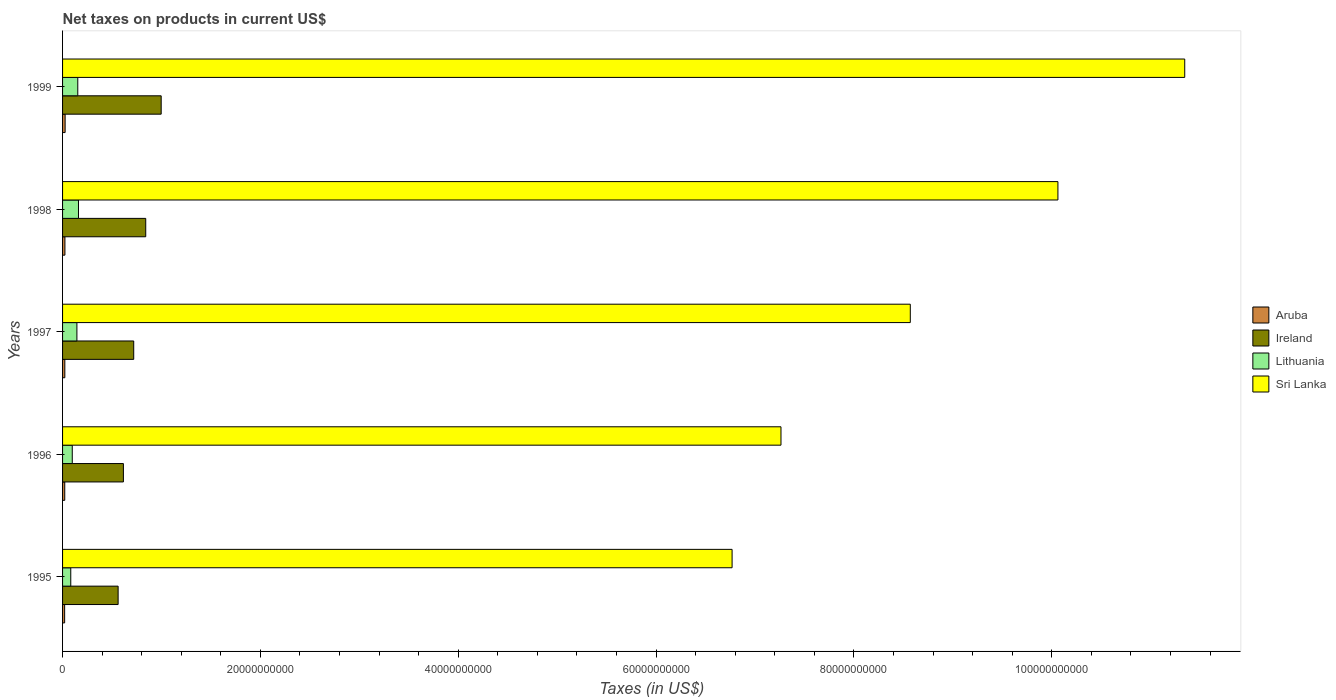How many different coloured bars are there?
Make the answer very short. 4. Are the number of bars per tick equal to the number of legend labels?
Your response must be concise. Yes. How many bars are there on the 4th tick from the top?
Offer a very short reply. 4. What is the label of the 5th group of bars from the top?
Provide a succinct answer. 1995. What is the net taxes on products in Ireland in 1998?
Provide a short and direct response. 8.41e+09. Across all years, what is the maximum net taxes on products in Aruba?
Your answer should be very brief. 2.59e+08. Across all years, what is the minimum net taxes on products in Aruba?
Provide a succinct answer. 2.09e+08. In which year was the net taxes on products in Aruba maximum?
Provide a succinct answer. 1999. In which year was the net taxes on products in Lithuania minimum?
Provide a short and direct response. 1995. What is the total net taxes on products in Ireland in the graph?
Provide a short and direct response. 3.73e+1. What is the difference between the net taxes on products in Ireland in 1998 and that in 1999?
Make the answer very short. -1.56e+09. What is the difference between the net taxes on products in Sri Lanka in 1998 and the net taxes on products in Lithuania in 1995?
Provide a succinct answer. 9.98e+1. What is the average net taxes on products in Ireland per year?
Ensure brevity in your answer.  7.47e+09. In the year 1998, what is the difference between the net taxes on products in Aruba and net taxes on products in Lithuania?
Make the answer very short. -1.37e+09. In how many years, is the net taxes on products in Lithuania greater than 84000000000 US$?
Keep it short and to the point. 0. What is the ratio of the net taxes on products in Lithuania in 1998 to that in 1999?
Your answer should be very brief. 1.05. Is the difference between the net taxes on products in Aruba in 1996 and 1999 greater than the difference between the net taxes on products in Lithuania in 1996 and 1999?
Your answer should be compact. Yes. What is the difference between the highest and the second highest net taxes on products in Ireland?
Your answer should be compact. 1.56e+09. What is the difference between the highest and the lowest net taxes on products in Ireland?
Offer a very short reply. 4.35e+09. In how many years, is the net taxes on products in Ireland greater than the average net taxes on products in Ireland taken over all years?
Your answer should be compact. 2. Is it the case that in every year, the sum of the net taxes on products in Sri Lanka and net taxes on products in Lithuania is greater than the sum of net taxes on products in Ireland and net taxes on products in Aruba?
Your response must be concise. Yes. What does the 3rd bar from the top in 1998 represents?
Your answer should be very brief. Ireland. What does the 2nd bar from the bottom in 1999 represents?
Your response must be concise. Ireland. How many bars are there?
Keep it short and to the point. 20. Are all the bars in the graph horizontal?
Offer a terse response. Yes. What is the difference between two consecutive major ticks on the X-axis?
Keep it short and to the point. 2.00e+1. Are the values on the major ticks of X-axis written in scientific E-notation?
Offer a very short reply. No. Does the graph contain any zero values?
Keep it short and to the point. No. Where does the legend appear in the graph?
Offer a very short reply. Center right. How are the legend labels stacked?
Ensure brevity in your answer.  Vertical. What is the title of the graph?
Keep it short and to the point. Net taxes on products in current US$. Does "Europe(developing only)" appear as one of the legend labels in the graph?
Ensure brevity in your answer.  No. What is the label or title of the X-axis?
Your answer should be compact. Taxes (in US$). What is the Taxes (in US$) in Aruba in 1995?
Offer a very short reply. 2.09e+08. What is the Taxes (in US$) of Ireland in 1995?
Your answer should be very brief. 5.62e+09. What is the Taxes (in US$) in Lithuania in 1995?
Make the answer very short. 8.29e+08. What is the Taxes (in US$) of Sri Lanka in 1995?
Ensure brevity in your answer.  6.77e+1. What is the Taxes (in US$) of Aruba in 1996?
Your response must be concise. 2.21e+08. What is the Taxes (in US$) of Ireland in 1996?
Offer a very short reply. 6.15e+09. What is the Taxes (in US$) in Lithuania in 1996?
Offer a terse response. 9.80e+08. What is the Taxes (in US$) of Sri Lanka in 1996?
Offer a very short reply. 7.26e+1. What is the Taxes (in US$) in Aruba in 1997?
Give a very brief answer. 2.29e+08. What is the Taxes (in US$) in Ireland in 1997?
Make the answer very short. 7.19e+09. What is the Taxes (in US$) in Lithuania in 1997?
Your answer should be compact. 1.45e+09. What is the Taxes (in US$) in Sri Lanka in 1997?
Ensure brevity in your answer.  8.57e+1. What is the Taxes (in US$) in Aruba in 1998?
Ensure brevity in your answer.  2.38e+08. What is the Taxes (in US$) of Ireland in 1998?
Your answer should be compact. 8.41e+09. What is the Taxes (in US$) in Lithuania in 1998?
Keep it short and to the point. 1.61e+09. What is the Taxes (in US$) in Sri Lanka in 1998?
Your answer should be compact. 1.01e+11. What is the Taxes (in US$) of Aruba in 1999?
Your answer should be very brief. 2.59e+08. What is the Taxes (in US$) of Ireland in 1999?
Ensure brevity in your answer.  9.97e+09. What is the Taxes (in US$) in Lithuania in 1999?
Your answer should be compact. 1.54e+09. What is the Taxes (in US$) in Sri Lanka in 1999?
Your response must be concise. 1.13e+11. Across all years, what is the maximum Taxes (in US$) of Aruba?
Offer a very short reply. 2.59e+08. Across all years, what is the maximum Taxes (in US$) in Ireland?
Ensure brevity in your answer.  9.97e+09. Across all years, what is the maximum Taxes (in US$) of Lithuania?
Make the answer very short. 1.61e+09. Across all years, what is the maximum Taxes (in US$) of Sri Lanka?
Your answer should be compact. 1.13e+11. Across all years, what is the minimum Taxes (in US$) in Aruba?
Offer a very short reply. 2.09e+08. Across all years, what is the minimum Taxes (in US$) in Ireland?
Give a very brief answer. 5.62e+09. Across all years, what is the minimum Taxes (in US$) in Lithuania?
Provide a short and direct response. 8.29e+08. Across all years, what is the minimum Taxes (in US$) in Sri Lanka?
Ensure brevity in your answer.  6.77e+1. What is the total Taxes (in US$) of Aruba in the graph?
Keep it short and to the point. 1.16e+09. What is the total Taxes (in US$) in Ireland in the graph?
Your answer should be very brief. 3.73e+1. What is the total Taxes (in US$) of Lithuania in the graph?
Offer a very short reply. 6.41e+09. What is the total Taxes (in US$) in Sri Lanka in the graph?
Your answer should be compact. 4.40e+11. What is the difference between the Taxes (in US$) in Aruba in 1995 and that in 1996?
Provide a short and direct response. -1.20e+07. What is the difference between the Taxes (in US$) of Ireland in 1995 and that in 1996?
Your response must be concise. -5.33e+08. What is the difference between the Taxes (in US$) of Lithuania in 1995 and that in 1996?
Offer a terse response. -1.52e+08. What is the difference between the Taxes (in US$) of Sri Lanka in 1995 and that in 1996?
Give a very brief answer. -4.94e+09. What is the difference between the Taxes (in US$) of Aruba in 1995 and that in 1997?
Ensure brevity in your answer.  -2.00e+07. What is the difference between the Taxes (in US$) in Ireland in 1995 and that in 1997?
Provide a short and direct response. -1.58e+09. What is the difference between the Taxes (in US$) in Lithuania in 1995 and that in 1997?
Provide a succinct answer. -6.21e+08. What is the difference between the Taxes (in US$) in Sri Lanka in 1995 and that in 1997?
Make the answer very short. -1.80e+1. What is the difference between the Taxes (in US$) in Aruba in 1995 and that in 1998?
Give a very brief answer. -2.95e+07. What is the difference between the Taxes (in US$) of Ireland in 1995 and that in 1998?
Offer a very short reply. -2.79e+09. What is the difference between the Taxes (in US$) of Lithuania in 1995 and that in 1998?
Provide a succinct answer. -7.80e+08. What is the difference between the Taxes (in US$) of Sri Lanka in 1995 and that in 1998?
Give a very brief answer. -3.29e+1. What is the difference between the Taxes (in US$) in Aruba in 1995 and that in 1999?
Offer a terse response. -4.98e+07. What is the difference between the Taxes (in US$) in Ireland in 1995 and that in 1999?
Your answer should be very brief. -4.35e+09. What is the difference between the Taxes (in US$) of Lithuania in 1995 and that in 1999?
Your answer should be very brief. -7.10e+08. What is the difference between the Taxes (in US$) of Sri Lanka in 1995 and that in 1999?
Give a very brief answer. -4.58e+1. What is the difference between the Taxes (in US$) of Aruba in 1996 and that in 1997?
Your answer should be compact. -8.00e+06. What is the difference between the Taxes (in US$) in Ireland in 1996 and that in 1997?
Offer a very short reply. -1.04e+09. What is the difference between the Taxes (in US$) in Lithuania in 1996 and that in 1997?
Make the answer very short. -4.69e+08. What is the difference between the Taxes (in US$) in Sri Lanka in 1996 and that in 1997?
Ensure brevity in your answer.  -1.31e+1. What is the difference between the Taxes (in US$) in Aruba in 1996 and that in 1998?
Keep it short and to the point. -1.75e+07. What is the difference between the Taxes (in US$) of Ireland in 1996 and that in 1998?
Your answer should be very brief. -2.26e+09. What is the difference between the Taxes (in US$) of Lithuania in 1996 and that in 1998?
Provide a succinct answer. -6.28e+08. What is the difference between the Taxes (in US$) in Sri Lanka in 1996 and that in 1998?
Ensure brevity in your answer.  -2.80e+1. What is the difference between the Taxes (in US$) of Aruba in 1996 and that in 1999?
Offer a terse response. -3.78e+07. What is the difference between the Taxes (in US$) of Ireland in 1996 and that in 1999?
Your response must be concise. -3.82e+09. What is the difference between the Taxes (in US$) of Lithuania in 1996 and that in 1999?
Give a very brief answer. -5.58e+08. What is the difference between the Taxes (in US$) in Sri Lanka in 1996 and that in 1999?
Give a very brief answer. -4.08e+1. What is the difference between the Taxes (in US$) of Aruba in 1997 and that in 1998?
Offer a terse response. -9.46e+06. What is the difference between the Taxes (in US$) of Ireland in 1997 and that in 1998?
Provide a short and direct response. -1.21e+09. What is the difference between the Taxes (in US$) of Lithuania in 1997 and that in 1998?
Make the answer very short. -1.60e+08. What is the difference between the Taxes (in US$) of Sri Lanka in 1997 and that in 1998?
Offer a terse response. -1.49e+1. What is the difference between the Taxes (in US$) of Aruba in 1997 and that in 1999?
Make the answer very short. -2.98e+07. What is the difference between the Taxes (in US$) in Ireland in 1997 and that in 1999?
Your answer should be compact. -2.78e+09. What is the difference between the Taxes (in US$) of Lithuania in 1997 and that in 1999?
Your response must be concise. -8.92e+07. What is the difference between the Taxes (in US$) in Sri Lanka in 1997 and that in 1999?
Your answer should be very brief. -2.77e+1. What is the difference between the Taxes (in US$) in Aruba in 1998 and that in 1999?
Your answer should be compact. -2.03e+07. What is the difference between the Taxes (in US$) of Ireland in 1998 and that in 1999?
Make the answer very short. -1.56e+09. What is the difference between the Taxes (in US$) of Lithuania in 1998 and that in 1999?
Keep it short and to the point. 7.05e+07. What is the difference between the Taxes (in US$) of Sri Lanka in 1998 and that in 1999?
Keep it short and to the point. -1.28e+1. What is the difference between the Taxes (in US$) in Aruba in 1995 and the Taxes (in US$) in Ireland in 1996?
Your answer should be compact. -5.94e+09. What is the difference between the Taxes (in US$) in Aruba in 1995 and the Taxes (in US$) in Lithuania in 1996?
Offer a terse response. -7.71e+08. What is the difference between the Taxes (in US$) in Aruba in 1995 and the Taxes (in US$) in Sri Lanka in 1996?
Make the answer very short. -7.24e+1. What is the difference between the Taxes (in US$) of Ireland in 1995 and the Taxes (in US$) of Lithuania in 1996?
Give a very brief answer. 4.64e+09. What is the difference between the Taxes (in US$) of Ireland in 1995 and the Taxes (in US$) of Sri Lanka in 1996?
Your answer should be very brief. -6.70e+1. What is the difference between the Taxes (in US$) in Lithuania in 1995 and the Taxes (in US$) in Sri Lanka in 1996?
Offer a terse response. -7.18e+1. What is the difference between the Taxes (in US$) of Aruba in 1995 and the Taxes (in US$) of Ireland in 1997?
Offer a terse response. -6.98e+09. What is the difference between the Taxes (in US$) of Aruba in 1995 and the Taxes (in US$) of Lithuania in 1997?
Ensure brevity in your answer.  -1.24e+09. What is the difference between the Taxes (in US$) in Aruba in 1995 and the Taxes (in US$) in Sri Lanka in 1997?
Your answer should be compact. -8.55e+1. What is the difference between the Taxes (in US$) of Ireland in 1995 and the Taxes (in US$) of Lithuania in 1997?
Ensure brevity in your answer.  4.17e+09. What is the difference between the Taxes (in US$) of Ireland in 1995 and the Taxes (in US$) of Sri Lanka in 1997?
Ensure brevity in your answer.  -8.01e+1. What is the difference between the Taxes (in US$) in Lithuania in 1995 and the Taxes (in US$) in Sri Lanka in 1997?
Offer a very short reply. -8.49e+1. What is the difference between the Taxes (in US$) in Aruba in 1995 and the Taxes (in US$) in Ireland in 1998?
Provide a short and direct response. -8.20e+09. What is the difference between the Taxes (in US$) in Aruba in 1995 and the Taxes (in US$) in Lithuania in 1998?
Keep it short and to the point. -1.40e+09. What is the difference between the Taxes (in US$) of Aruba in 1995 and the Taxes (in US$) of Sri Lanka in 1998?
Ensure brevity in your answer.  -1.00e+11. What is the difference between the Taxes (in US$) of Ireland in 1995 and the Taxes (in US$) of Lithuania in 1998?
Your response must be concise. 4.01e+09. What is the difference between the Taxes (in US$) of Ireland in 1995 and the Taxes (in US$) of Sri Lanka in 1998?
Your answer should be very brief. -9.50e+1. What is the difference between the Taxes (in US$) of Lithuania in 1995 and the Taxes (in US$) of Sri Lanka in 1998?
Offer a terse response. -9.98e+1. What is the difference between the Taxes (in US$) of Aruba in 1995 and the Taxes (in US$) of Ireland in 1999?
Your answer should be very brief. -9.76e+09. What is the difference between the Taxes (in US$) in Aruba in 1995 and the Taxes (in US$) in Lithuania in 1999?
Provide a succinct answer. -1.33e+09. What is the difference between the Taxes (in US$) in Aruba in 1995 and the Taxes (in US$) in Sri Lanka in 1999?
Your answer should be very brief. -1.13e+11. What is the difference between the Taxes (in US$) in Ireland in 1995 and the Taxes (in US$) in Lithuania in 1999?
Your answer should be compact. 4.08e+09. What is the difference between the Taxes (in US$) of Ireland in 1995 and the Taxes (in US$) of Sri Lanka in 1999?
Your answer should be very brief. -1.08e+11. What is the difference between the Taxes (in US$) in Lithuania in 1995 and the Taxes (in US$) in Sri Lanka in 1999?
Your answer should be compact. -1.13e+11. What is the difference between the Taxes (in US$) in Aruba in 1996 and the Taxes (in US$) in Ireland in 1997?
Keep it short and to the point. -6.97e+09. What is the difference between the Taxes (in US$) of Aruba in 1996 and the Taxes (in US$) of Lithuania in 1997?
Ensure brevity in your answer.  -1.23e+09. What is the difference between the Taxes (in US$) of Aruba in 1996 and the Taxes (in US$) of Sri Lanka in 1997?
Give a very brief answer. -8.55e+1. What is the difference between the Taxes (in US$) in Ireland in 1996 and the Taxes (in US$) in Lithuania in 1997?
Provide a short and direct response. 4.70e+09. What is the difference between the Taxes (in US$) in Ireland in 1996 and the Taxes (in US$) in Sri Lanka in 1997?
Keep it short and to the point. -7.95e+1. What is the difference between the Taxes (in US$) in Lithuania in 1996 and the Taxes (in US$) in Sri Lanka in 1997?
Offer a very short reply. -8.47e+1. What is the difference between the Taxes (in US$) in Aruba in 1996 and the Taxes (in US$) in Ireland in 1998?
Give a very brief answer. -8.19e+09. What is the difference between the Taxes (in US$) in Aruba in 1996 and the Taxes (in US$) in Lithuania in 1998?
Provide a short and direct response. -1.39e+09. What is the difference between the Taxes (in US$) of Aruba in 1996 and the Taxes (in US$) of Sri Lanka in 1998?
Give a very brief answer. -1.00e+11. What is the difference between the Taxes (in US$) of Ireland in 1996 and the Taxes (in US$) of Lithuania in 1998?
Your answer should be compact. 4.54e+09. What is the difference between the Taxes (in US$) in Ireland in 1996 and the Taxes (in US$) in Sri Lanka in 1998?
Offer a very short reply. -9.45e+1. What is the difference between the Taxes (in US$) in Lithuania in 1996 and the Taxes (in US$) in Sri Lanka in 1998?
Give a very brief answer. -9.96e+1. What is the difference between the Taxes (in US$) in Aruba in 1996 and the Taxes (in US$) in Ireland in 1999?
Give a very brief answer. -9.75e+09. What is the difference between the Taxes (in US$) of Aruba in 1996 and the Taxes (in US$) of Lithuania in 1999?
Provide a succinct answer. -1.32e+09. What is the difference between the Taxes (in US$) of Aruba in 1996 and the Taxes (in US$) of Sri Lanka in 1999?
Your response must be concise. -1.13e+11. What is the difference between the Taxes (in US$) in Ireland in 1996 and the Taxes (in US$) in Lithuania in 1999?
Ensure brevity in your answer.  4.61e+09. What is the difference between the Taxes (in US$) of Ireland in 1996 and the Taxes (in US$) of Sri Lanka in 1999?
Make the answer very short. -1.07e+11. What is the difference between the Taxes (in US$) in Lithuania in 1996 and the Taxes (in US$) in Sri Lanka in 1999?
Your answer should be very brief. -1.12e+11. What is the difference between the Taxes (in US$) in Aruba in 1997 and the Taxes (in US$) in Ireland in 1998?
Offer a very short reply. -8.18e+09. What is the difference between the Taxes (in US$) in Aruba in 1997 and the Taxes (in US$) in Lithuania in 1998?
Provide a short and direct response. -1.38e+09. What is the difference between the Taxes (in US$) in Aruba in 1997 and the Taxes (in US$) in Sri Lanka in 1998?
Keep it short and to the point. -1.00e+11. What is the difference between the Taxes (in US$) in Ireland in 1997 and the Taxes (in US$) in Lithuania in 1998?
Make the answer very short. 5.58e+09. What is the difference between the Taxes (in US$) of Ireland in 1997 and the Taxes (in US$) of Sri Lanka in 1998?
Make the answer very short. -9.34e+1. What is the difference between the Taxes (in US$) in Lithuania in 1997 and the Taxes (in US$) in Sri Lanka in 1998?
Offer a terse response. -9.92e+1. What is the difference between the Taxes (in US$) in Aruba in 1997 and the Taxes (in US$) in Ireland in 1999?
Your answer should be compact. -9.74e+09. What is the difference between the Taxes (in US$) of Aruba in 1997 and the Taxes (in US$) of Lithuania in 1999?
Offer a very short reply. -1.31e+09. What is the difference between the Taxes (in US$) of Aruba in 1997 and the Taxes (in US$) of Sri Lanka in 1999?
Make the answer very short. -1.13e+11. What is the difference between the Taxes (in US$) of Ireland in 1997 and the Taxes (in US$) of Lithuania in 1999?
Keep it short and to the point. 5.65e+09. What is the difference between the Taxes (in US$) in Ireland in 1997 and the Taxes (in US$) in Sri Lanka in 1999?
Provide a succinct answer. -1.06e+11. What is the difference between the Taxes (in US$) in Lithuania in 1997 and the Taxes (in US$) in Sri Lanka in 1999?
Your answer should be compact. -1.12e+11. What is the difference between the Taxes (in US$) in Aruba in 1998 and the Taxes (in US$) in Ireland in 1999?
Provide a short and direct response. -9.73e+09. What is the difference between the Taxes (in US$) of Aruba in 1998 and the Taxes (in US$) of Lithuania in 1999?
Keep it short and to the point. -1.30e+09. What is the difference between the Taxes (in US$) in Aruba in 1998 and the Taxes (in US$) in Sri Lanka in 1999?
Make the answer very short. -1.13e+11. What is the difference between the Taxes (in US$) in Ireland in 1998 and the Taxes (in US$) in Lithuania in 1999?
Offer a very short reply. 6.87e+09. What is the difference between the Taxes (in US$) in Ireland in 1998 and the Taxes (in US$) in Sri Lanka in 1999?
Your answer should be very brief. -1.05e+11. What is the difference between the Taxes (in US$) in Lithuania in 1998 and the Taxes (in US$) in Sri Lanka in 1999?
Keep it short and to the point. -1.12e+11. What is the average Taxes (in US$) of Aruba per year?
Ensure brevity in your answer.  2.31e+08. What is the average Taxes (in US$) in Ireland per year?
Give a very brief answer. 7.47e+09. What is the average Taxes (in US$) of Lithuania per year?
Your answer should be compact. 1.28e+09. What is the average Taxes (in US$) of Sri Lanka per year?
Your response must be concise. 8.80e+1. In the year 1995, what is the difference between the Taxes (in US$) in Aruba and Taxes (in US$) in Ireland?
Your answer should be very brief. -5.41e+09. In the year 1995, what is the difference between the Taxes (in US$) of Aruba and Taxes (in US$) of Lithuania?
Offer a very short reply. -6.20e+08. In the year 1995, what is the difference between the Taxes (in US$) in Aruba and Taxes (in US$) in Sri Lanka?
Make the answer very short. -6.75e+1. In the year 1995, what is the difference between the Taxes (in US$) in Ireland and Taxes (in US$) in Lithuania?
Provide a succinct answer. 4.79e+09. In the year 1995, what is the difference between the Taxes (in US$) in Ireland and Taxes (in US$) in Sri Lanka?
Keep it short and to the point. -6.21e+1. In the year 1995, what is the difference between the Taxes (in US$) of Lithuania and Taxes (in US$) of Sri Lanka?
Provide a succinct answer. -6.69e+1. In the year 1996, what is the difference between the Taxes (in US$) in Aruba and Taxes (in US$) in Ireland?
Your response must be concise. -5.93e+09. In the year 1996, what is the difference between the Taxes (in US$) in Aruba and Taxes (in US$) in Lithuania?
Offer a terse response. -7.59e+08. In the year 1996, what is the difference between the Taxes (in US$) of Aruba and Taxes (in US$) of Sri Lanka?
Give a very brief answer. -7.24e+1. In the year 1996, what is the difference between the Taxes (in US$) in Ireland and Taxes (in US$) in Lithuania?
Offer a very short reply. 5.17e+09. In the year 1996, what is the difference between the Taxes (in US$) in Ireland and Taxes (in US$) in Sri Lanka?
Your response must be concise. -6.65e+1. In the year 1996, what is the difference between the Taxes (in US$) of Lithuania and Taxes (in US$) of Sri Lanka?
Keep it short and to the point. -7.16e+1. In the year 1997, what is the difference between the Taxes (in US$) in Aruba and Taxes (in US$) in Ireland?
Give a very brief answer. -6.96e+09. In the year 1997, what is the difference between the Taxes (in US$) in Aruba and Taxes (in US$) in Lithuania?
Provide a short and direct response. -1.22e+09. In the year 1997, what is the difference between the Taxes (in US$) of Aruba and Taxes (in US$) of Sri Lanka?
Offer a terse response. -8.55e+1. In the year 1997, what is the difference between the Taxes (in US$) in Ireland and Taxes (in US$) in Lithuania?
Make the answer very short. 5.74e+09. In the year 1997, what is the difference between the Taxes (in US$) in Ireland and Taxes (in US$) in Sri Lanka?
Offer a very short reply. -7.85e+1. In the year 1997, what is the difference between the Taxes (in US$) in Lithuania and Taxes (in US$) in Sri Lanka?
Offer a terse response. -8.42e+1. In the year 1998, what is the difference between the Taxes (in US$) of Aruba and Taxes (in US$) of Ireland?
Make the answer very short. -8.17e+09. In the year 1998, what is the difference between the Taxes (in US$) of Aruba and Taxes (in US$) of Lithuania?
Provide a short and direct response. -1.37e+09. In the year 1998, what is the difference between the Taxes (in US$) in Aruba and Taxes (in US$) in Sri Lanka?
Make the answer very short. -1.00e+11. In the year 1998, what is the difference between the Taxes (in US$) in Ireland and Taxes (in US$) in Lithuania?
Provide a succinct answer. 6.80e+09. In the year 1998, what is the difference between the Taxes (in US$) of Ireland and Taxes (in US$) of Sri Lanka?
Offer a very short reply. -9.22e+1. In the year 1998, what is the difference between the Taxes (in US$) of Lithuania and Taxes (in US$) of Sri Lanka?
Your answer should be very brief. -9.90e+1. In the year 1999, what is the difference between the Taxes (in US$) in Aruba and Taxes (in US$) in Ireland?
Your answer should be very brief. -9.71e+09. In the year 1999, what is the difference between the Taxes (in US$) in Aruba and Taxes (in US$) in Lithuania?
Provide a short and direct response. -1.28e+09. In the year 1999, what is the difference between the Taxes (in US$) in Aruba and Taxes (in US$) in Sri Lanka?
Provide a short and direct response. -1.13e+11. In the year 1999, what is the difference between the Taxes (in US$) in Ireland and Taxes (in US$) in Lithuania?
Offer a very short reply. 8.43e+09. In the year 1999, what is the difference between the Taxes (in US$) of Ireland and Taxes (in US$) of Sri Lanka?
Keep it short and to the point. -1.03e+11. In the year 1999, what is the difference between the Taxes (in US$) of Lithuania and Taxes (in US$) of Sri Lanka?
Your answer should be compact. -1.12e+11. What is the ratio of the Taxes (in US$) of Aruba in 1995 to that in 1996?
Your answer should be compact. 0.95. What is the ratio of the Taxes (in US$) of Ireland in 1995 to that in 1996?
Ensure brevity in your answer.  0.91. What is the ratio of the Taxes (in US$) of Lithuania in 1995 to that in 1996?
Offer a terse response. 0.85. What is the ratio of the Taxes (in US$) of Sri Lanka in 1995 to that in 1996?
Offer a terse response. 0.93. What is the ratio of the Taxes (in US$) of Aruba in 1995 to that in 1997?
Provide a succinct answer. 0.91. What is the ratio of the Taxes (in US$) of Ireland in 1995 to that in 1997?
Your answer should be very brief. 0.78. What is the ratio of the Taxes (in US$) in Lithuania in 1995 to that in 1997?
Your answer should be compact. 0.57. What is the ratio of the Taxes (in US$) in Sri Lanka in 1995 to that in 1997?
Your answer should be very brief. 0.79. What is the ratio of the Taxes (in US$) in Aruba in 1995 to that in 1998?
Your answer should be compact. 0.88. What is the ratio of the Taxes (in US$) of Ireland in 1995 to that in 1998?
Ensure brevity in your answer.  0.67. What is the ratio of the Taxes (in US$) in Lithuania in 1995 to that in 1998?
Your response must be concise. 0.52. What is the ratio of the Taxes (in US$) of Sri Lanka in 1995 to that in 1998?
Your answer should be very brief. 0.67. What is the ratio of the Taxes (in US$) of Aruba in 1995 to that in 1999?
Ensure brevity in your answer.  0.81. What is the ratio of the Taxes (in US$) in Ireland in 1995 to that in 1999?
Give a very brief answer. 0.56. What is the ratio of the Taxes (in US$) in Lithuania in 1995 to that in 1999?
Ensure brevity in your answer.  0.54. What is the ratio of the Taxes (in US$) of Sri Lanka in 1995 to that in 1999?
Provide a short and direct response. 0.6. What is the ratio of the Taxes (in US$) of Aruba in 1996 to that in 1997?
Offer a terse response. 0.97. What is the ratio of the Taxes (in US$) of Ireland in 1996 to that in 1997?
Provide a succinct answer. 0.85. What is the ratio of the Taxes (in US$) of Lithuania in 1996 to that in 1997?
Offer a terse response. 0.68. What is the ratio of the Taxes (in US$) in Sri Lanka in 1996 to that in 1997?
Keep it short and to the point. 0.85. What is the ratio of the Taxes (in US$) of Aruba in 1996 to that in 1998?
Make the answer very short. 0.93. What is the ratio of the Taxes (in US$) in Ireland in 1996 to that in 1998?
Your answer should be very brief. 0.73. What is the ratio of the Taxes (in US$) of Lithuania in 1996 to that in 1998?
Your response must be concise. 0.61. What is the ratio of the Taxes (in US$) in Sri Lanka in 1996 to that in 1998?
Provide a short and direct response. 0.72. What is the ratio of the Taxes (in US$) of Aruba in 1996 to that in 1999?
Give a very brief answer. 0.85. What is the ratio of the Taxes (in US$) of Ireland in 1996 to that in 1999?
Offer a very short reply. 0.62. What is the ratio of the Taxes (in US$) in Lithuania in 1996 to that in 1999?
Your answer should be very brief. 0.64. What is the ratio of the Taxes (in US$) of Sri Lanka in 1996 to that in 1999?
Provide a succinct answer. 0.64. What is the ratio of the Taxes (in US$) in Aruba in 1997 to that in 1998?
Offer a terse response. 0.96. What is the ratio of the Taxes (in US$) of Ireland in 1997 to that in 1998?
Your answer should be very brief. 0.86. What is the ratio of the Taxes (in US$) in Lithuania in 1997 to that in 1998?
Provide a short and direct response. 0.9. What is the ratio of the Taxes (in US$) of Sri Lanka in 1997 to that in 1998?
Make the answer very short. 0.85. What is the ratio of the Taxes (in US$) of Aruba in 1997 to that in 1999?
Offer a terse response. 0.89. What is the ratio of the Taxes (in US$) in Ireland in 1997 to that in 1999?
Provide a short and direct response. 0.72. What is the ratio of the Taxes (in US$) in Lithuania in 1997 to that in 1999?
Your answer should be compact. 0.94. What is the ratio of the Taxes (in US$) of Sri Lanka in 1997 to that in 1999?
Give a very brief answer. 0.76. What is the ratio of the Taxes (in US$) of Aruba in 1998 to that in 1999?
Ensure brevity in your answer.  0.92. What is the ratio of the Taxes (in US$) in Ireland in 1998 to that in 1999?
Ensure brevity in your answer.  0.84. What is the ratio of the Taxes (in US$) of Lithuania in 1998 to that in 1999?
Keep it short and to the point. 1.05. What is the ratio of the Taxes (in US$) of Sri Lanka in 1998 to that in 1999?
Make the answer very short. 0.89. What is the difference between the highest and the second highest Taxes (in US$) in Aruba?
Keep it short and to the point. 2.03e+07. What is the difference between the highest and the second highest Taxes (in US$) of Ireland?
Give a very brief answer. 1.56e+09. What is the difference between the highest and the second highest Taxes (in US$) of Lithuania?
Ensure brevity in your answer.  7.05e+07. What is the difference between the highest and the second highest Taxes (in US$) of Sri Lanka?
Your response must be concise. 1.28e+1. What is the difference between the highest and the lowest Taxes (in US$) in Aruba?
Keep it short and to the point. 4.98e+07. What is the difference between the highest and the lowest Taxes (in US$) in Ireland?
Your answer should be very brief. 4.35e+09. What is the difference between the highest and the lowest Taxes (in US$) in Lithuania?
Your answer should be compact. 7.80e+08. What is the difference between the highest and the lowest Taxes (in US$) in Sri Lanka?
Offer a very short reply. 4.58e+1. 